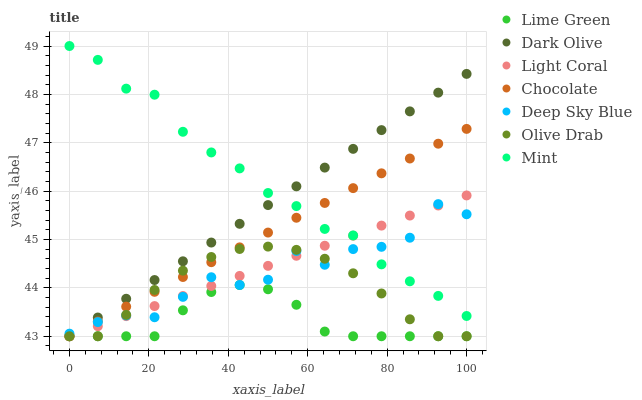Does Lime Green have the minimum area under the curve?
Answer yes or no. Yes. Does Mint have the maximum area under the curve?
Answer yes or no. Yes. Does Dark Olive have the minimum area under the curve?
Answer yes or no. No. Does Dark Olive have the maximum area under the curve?
Answer yes or no. No. Is Dark Olive the smoothest?
Answer yes or no. Yes. Is Deep Sky Blue the roughest?
Answer yes or no. Yes. Is Chocolate the smoothest?
Answer yes or no. No. Is Chocolate the roughest?
Answer yes or no. No. Does Dark Olive have the lowest value?
Answer yes or no. Yes. Does Deep Sky Blue have the lowest value?
Answer yes or no. No. Does Mint have the highest value?
Answer yes or no. Yes. Does Dark Olive have the highest value?
Answer yes or no. No. Is Olive Drab less than Mint?
Answer yes or no. Yes. Is Mint greater than Lime Green?
Answer yes or no. Yes. Does Dark Olive intersect Mint?
Answer yes or no. Yes. Is Dark Olive less than Mint?
Answer yes or no. No. Is Dark Olive greater than Mint?
Answer yes or no. No. Does Olive Drab intersect Mint?
Answer yes or no. No. 